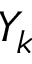Convert formula to latex. <formula><loc_0><loc_0><loc_500><loc_500>Y _ { k }</formula> 